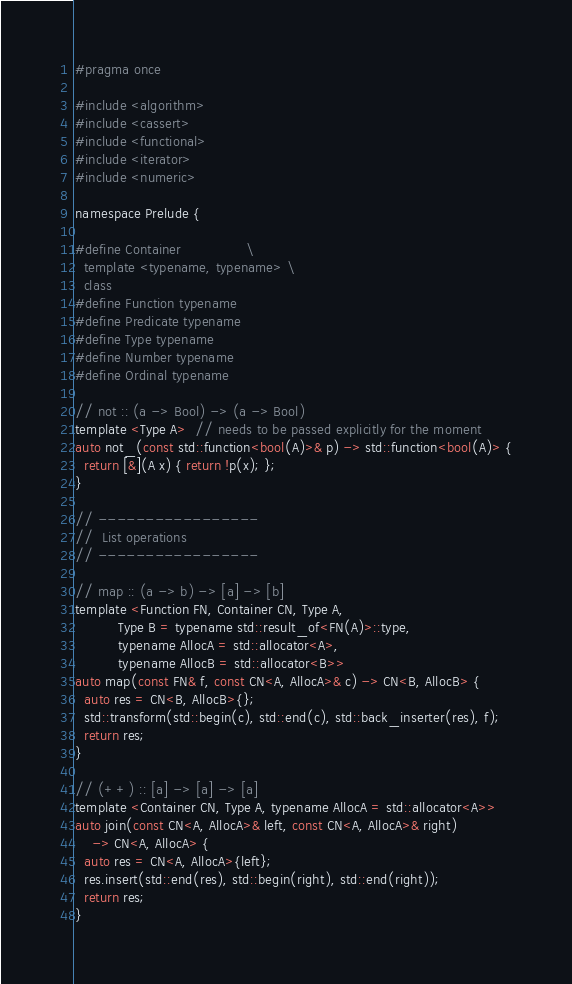<code> <loc_0><loc_0><loc_500><loc_500><_C_>#pragma once

#include <algorithm>
#include <cassert>
#include <functional>
#include <iterator>
#include <numeric>

namespace Prelude {

#define Container               \
  template <typename, typename> \
  class
#define Function typename
#define Predicate typename
#define Type typename
#define Number typename
#define Ordinal typename

// not :: (a -> Bool) -> (a -> Bool)
template <Type A>  // needs to be passed explicitly for the moment
auto not_(const std::function<bool(A)>& p) -> std::function<bool(A)> {
  return [&](A x) { return !p(x); };
}

// -----------------
//  List operations
// -----------------

// map :: (a -> b) -> [a] -> [b]
template <Function FN, Container CN, Type A,
          Type B = typename std::result_of<FN(A)>::type,
          typename AllocA = std::allocator<A>,
          typename AllocB = std::allocator<B>>
auto map(const FN& f, const CN<A, AllocA>& c) -> CN<B, AllocB> {
  auto res = CN<B, AllocB>{};
  std::transform(std::begin(c), std::end(c), std::back_inserter(res), f);
  return res;
}

// (++) :: [a] -> [a] -> [a]
template <Container CN, Type A, typename AllocA = std::allocator<A>>
auto join(const CN<A, AllocA>& left, const CN<A, AllocA>& right)
    -> CN<A, AllocA> {
  auto res = CN<A, AllocA>{left};
  res.insert(std::end(res), std::begin(right), std::end(right));
  return res;
}
</code> 